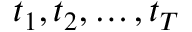<formula> <loc_0><loc_0><loc_500><loc_500>t _ { 1 } , t _ { 2 } , \dots , t _ { T }</formula> 